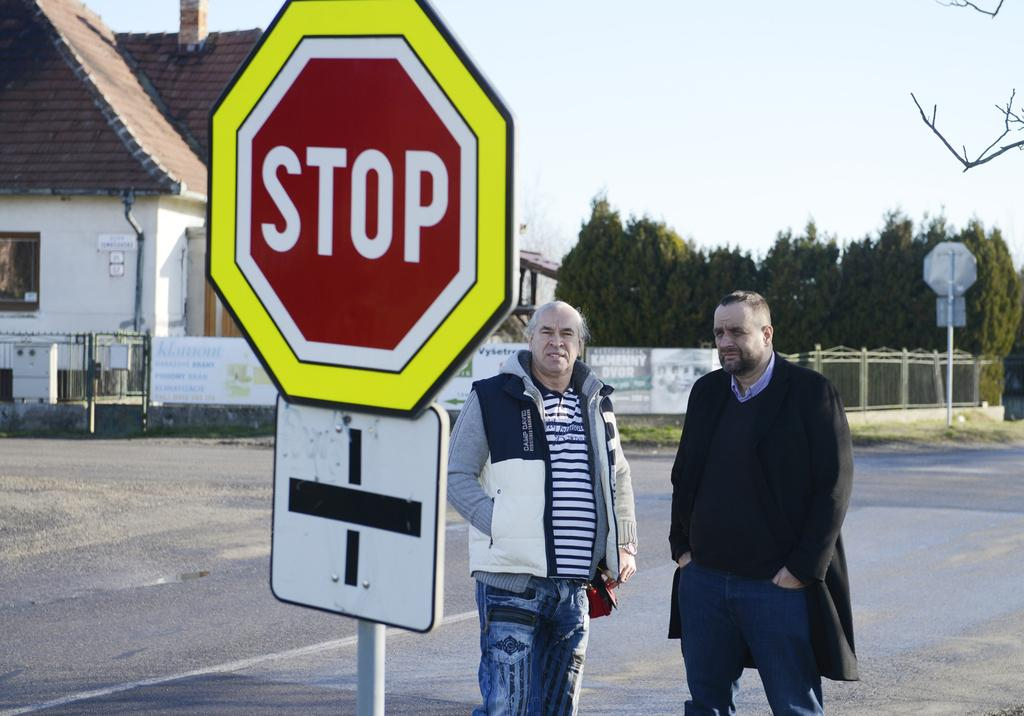<image>
Create a compact narrative representing the image presented. Two men stand behind a yellow, white and red stop sign. 